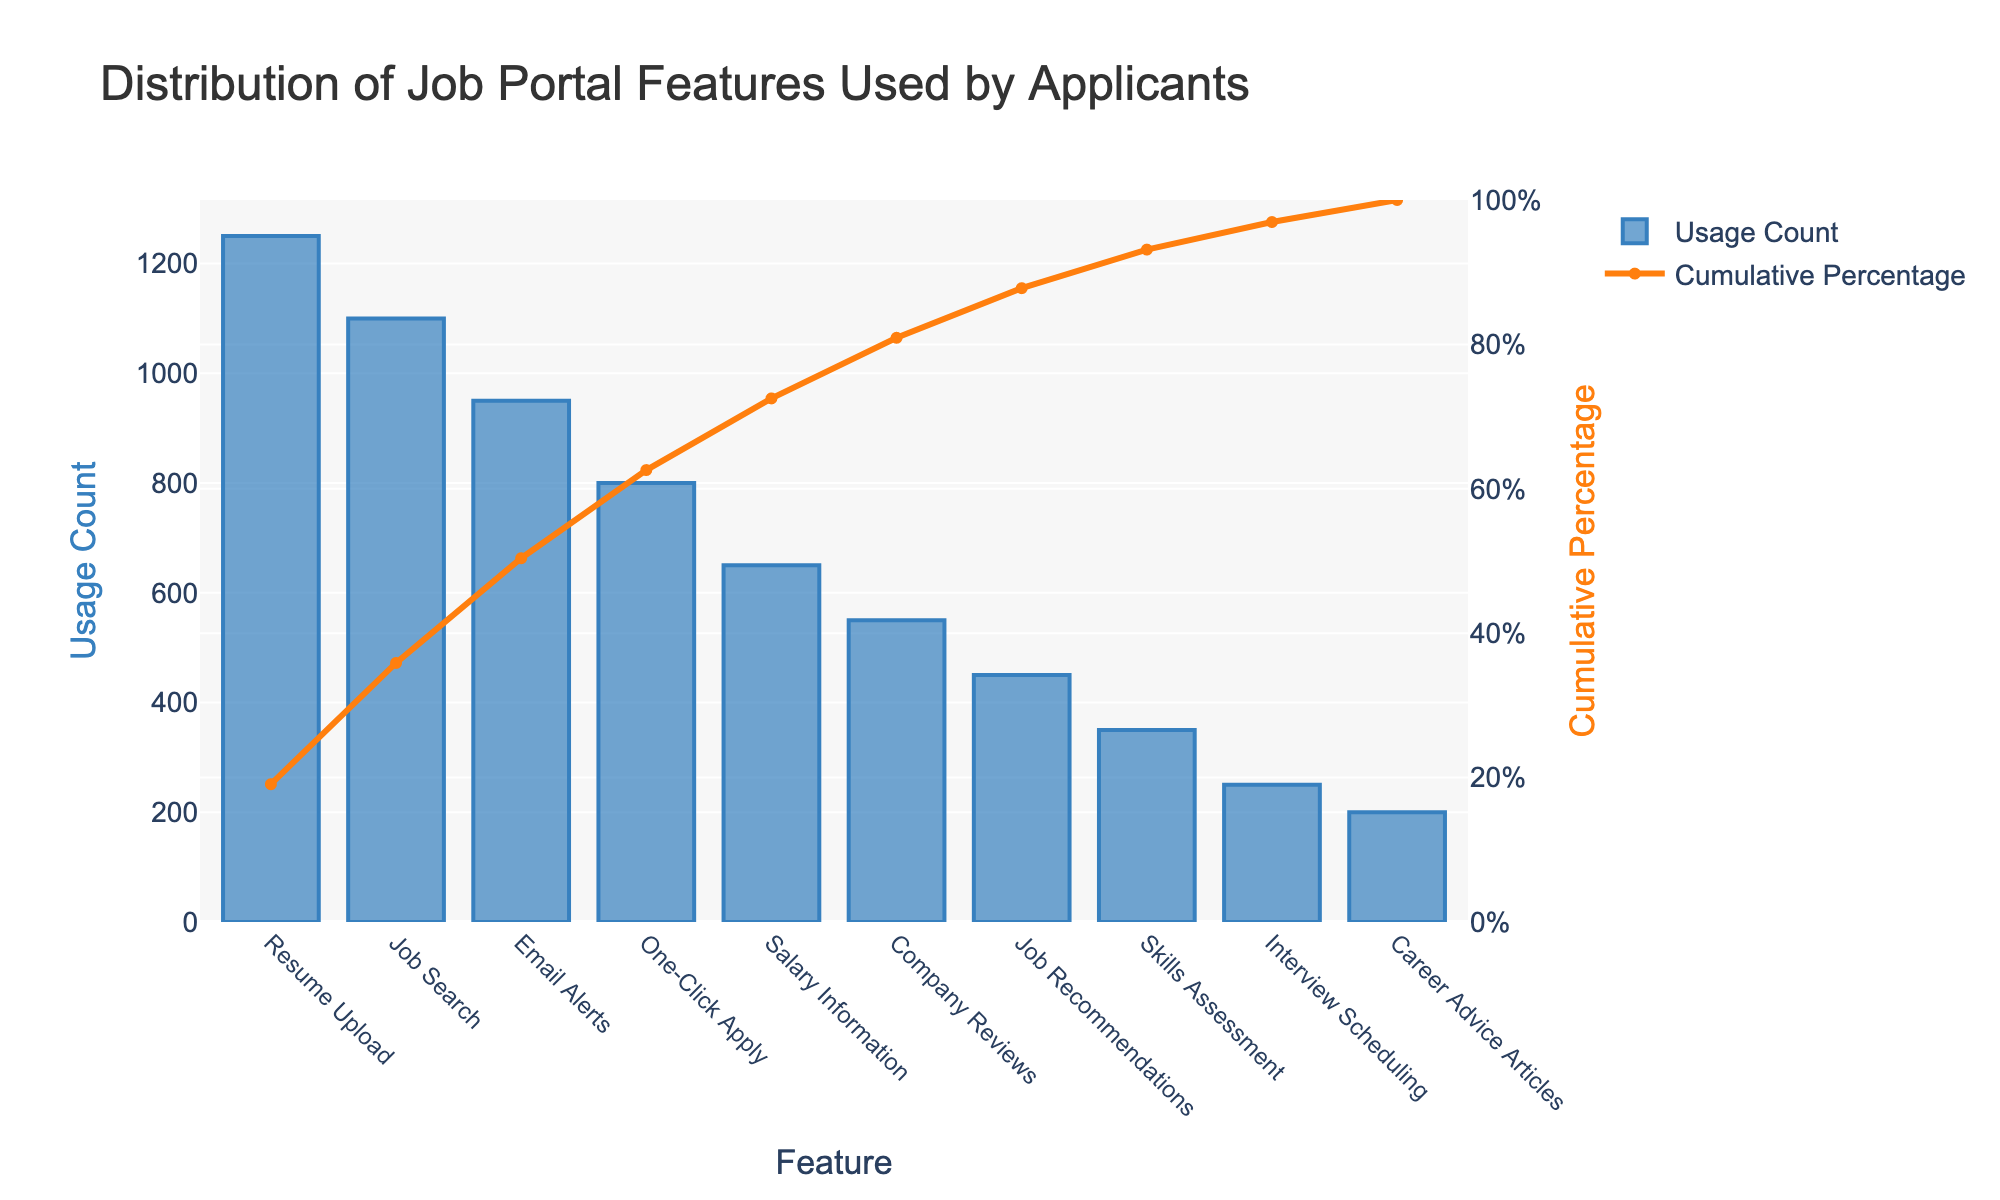What is the most frequently used job portal feature? The Pareto chart shows the features sorted by usage count. The tallest bar represents the most frequently used feature. According to the chart, "Resume Upload" has the highest usage count.
Answer: Resume Upload What is the cumulative percentage for the "One-Click Apply" feature? The cumulative percentage can be found by looking at the line corresponding to the "One-Click Apply" feature on the secondary y-axis (right side). For "One-Click Apply," the cumulative percentage is approximately 75%.
Answer: Approximately 75% How many features account for at least 80% of the total usage? Look at the cumulative percentage line and count the number of features until the cumulative percentage reaches at least 80%. "Resume Upload," "Job Search," "Email Alerts," and "One-Click Apply" add up to slightly more than 80%.
Answer: 4 features Which feature has a usage count of 950? Refer to the bars in the chart to find where the usage count reaches 950. According to the chart, "Email Alerts" has a usage count of 950.
Answer: Email Alerts Do more features have a usage count greater than or equal to 800 or less than 800? Count the features whose bars are equal to or taller than 800 and those which are shorter. Features with usage counts 1250, 1100, 950, and 800 are four, while those under 800 are six. Therefore, fewer features have usage counts greater than or equal to 800.
Answer: Less than 800 What is the cumulative percentage for the three least used features? Check the cumulative percentage line for the last three features: "Skills Assessment" (350), "Interview Scheduling" (250), and "Career Advice Articles" (200). The cumulative percentage at "Career Advice Articles" is slightly above 90%.
Answer: Slightly above 90% Which feature has the least usage count and what is its value? The shortest bar in the Pareto chart represents the feature with the least usage count. "Career Advice Articles" is the shortest bar with a usage count of 200.
Answer: Career Advice Articles, 200 By how much does the usage count of the "Salary Information" feature exceed that of "Company Reviews"? Find the usage counts for "Salary Information" and "Company Reviews" from the chart. The difference is 650 - 550 = 100.
Answer: 100 Which feature contributes to reaching approximately 60% cumulative percentage? Trace the cumulative percentage line until it reaches around 60% and see the corresponding feature beneath that point. "Email Alerts" marks roughly the 60% point.
Answer: Email Alerts How many features have a usage count less than 500? Count the number of bars that are below the 500 mark on the primary y-axis. The features are "Job Recommendations," "Skills Assessment," "Interview Scheduling," and "Career Advice Articles," totaling four features.
Answer: 4 features 